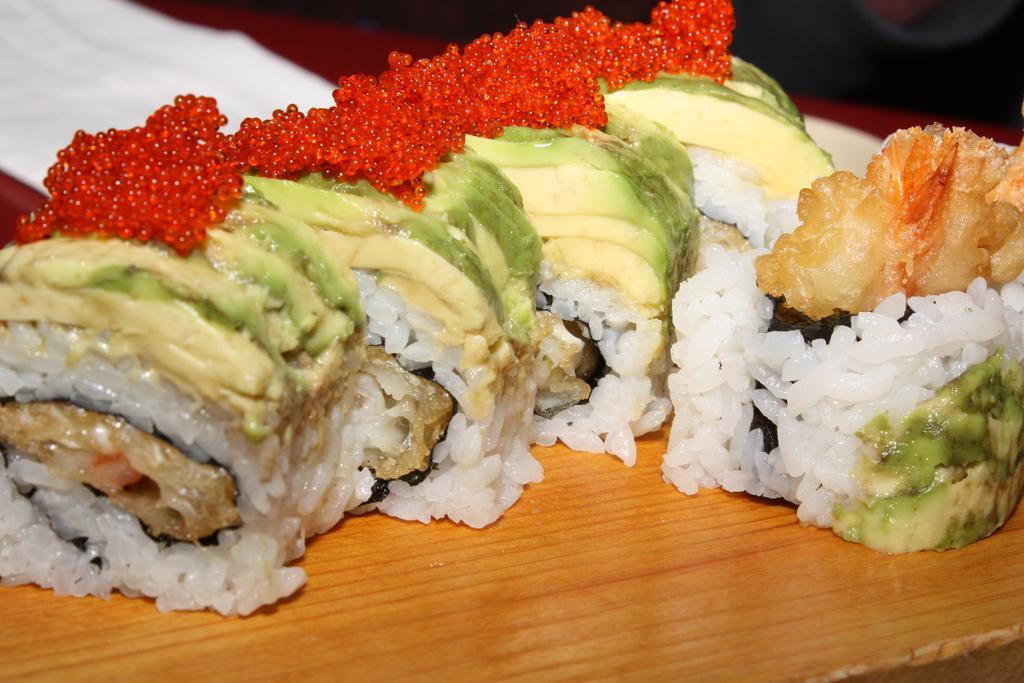Could you give a brief overview of what you see in this image? In this picture we can see food. 